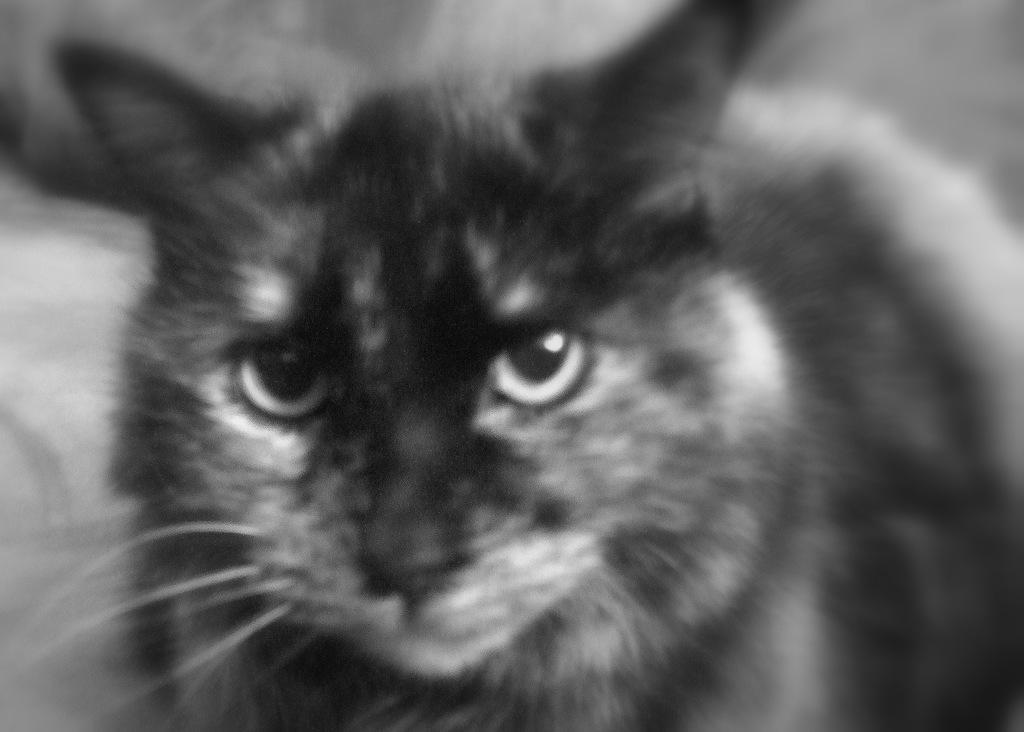Describe this image in one or two sentences. In the picture we can see a black and white image of a cat which is some part black in color and some part white in color. 